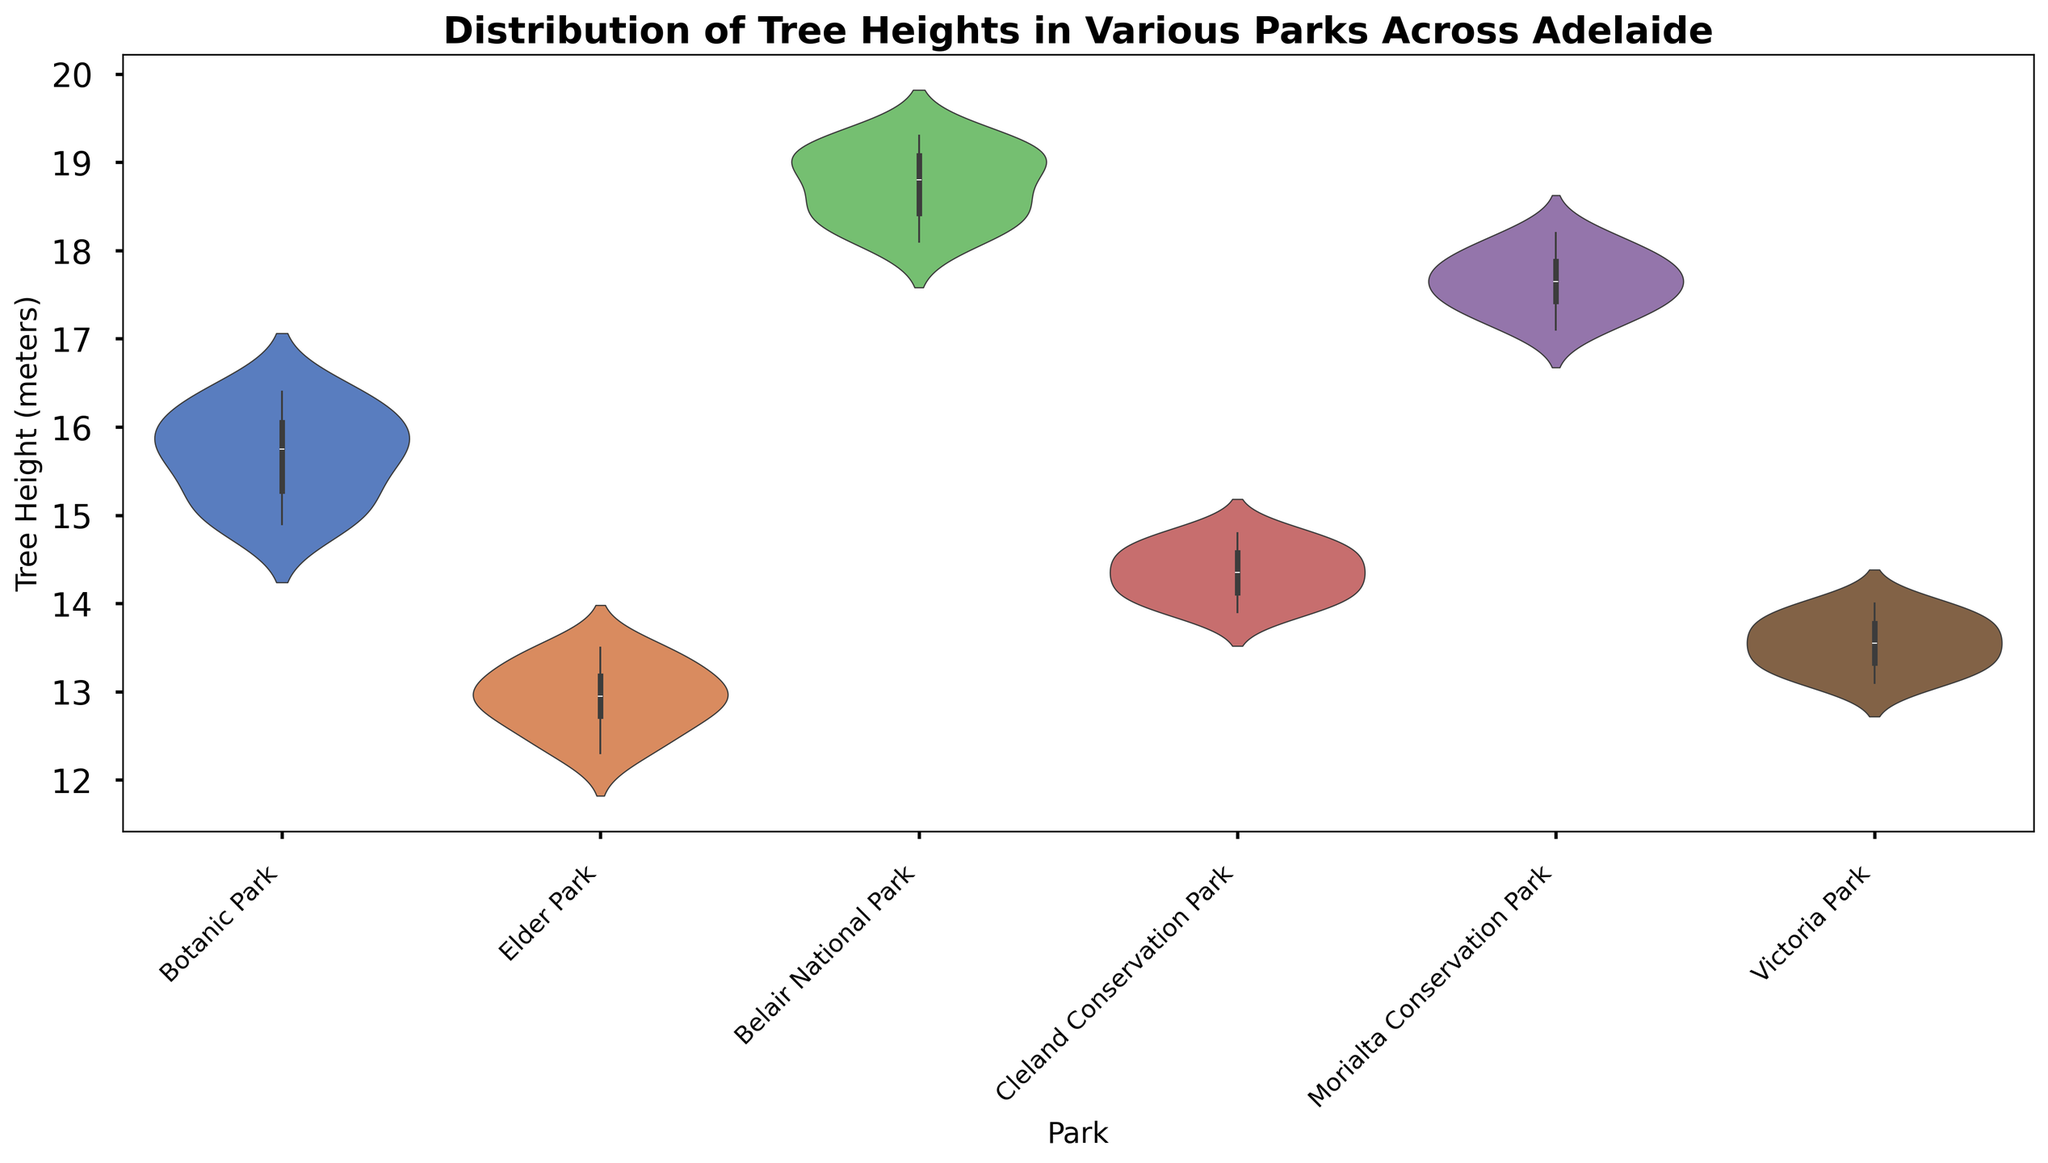Which park has the trees with the highest median height? By looking at the figure, the median height is represented by the thickest part at the middle of each violin. Comparing all the violins, Belair National Park has the highest median height.
Answer: Belair National Park Which park shows the greatest range of tree heights? The range of tree heights is the difference between the maximum and minimum values. By observing the width span of the violins in each park, Belair National Park has the widest span across the plot, indicating the greatest range of tree heights.
Answer: Belair National Park How does the median tree height in Botanic Park compare to Elder Park? Locate the median marks (widest part of the violins) on both parks. Botanic Park's median height is around 15.5 meters, while Elder Park's median is around 13 meters. Therefore, Botanic Park's median is greater.
Answer: Botanic Park's median is higher Which park has the highest variability in tree heights? The variability or spread can be visually assessed by the width and span of the violin plot. Belair National Park shows the largest spread indicating it has the highest variability in tree heights.
Answer: Belair National Park Which park has the shortest trees on average? By comparing the overall distribution indicated by the violins, Elder Park has the general lowest distribution, thus has the shortest trees on average.
Answer: Elder Park Compare the spread of tree heights between Cleland Conservation Park and Morialta Conservation Park. Which one is greater? Assess the spread by looking at the width and range of the violins. Morialta Conservation Park's violin spans a broader range over the x-axis, indicating a greater spread compared to Cleland Conservation Park.
Answer: Morialta Conservation Park What is the typical tree height range observed in Victoria Park? By observing the width of the violin plot for Victoria Park, the typical tree height ranges between 13.0 and 14.0 meters.
Answer: 13.0 to 14.0 meters How does the shape of the violin plot for Belair National Park differ from Botanic Park? The violin for Belair National Park is much wider and spans a taller height range, suggesting greater variability and higher tree heights compared to the more uniformly shaped and shorter Botanic Park violin.
Answer: Belair National Park has a wider and taller span Based on the plot, which park would you recommend for a tour focused on seeing the tallest trees? Tallest trees are represented in Belair National Park as its distribution extends to the highest values in the plot.
Answer: Belair National Park 